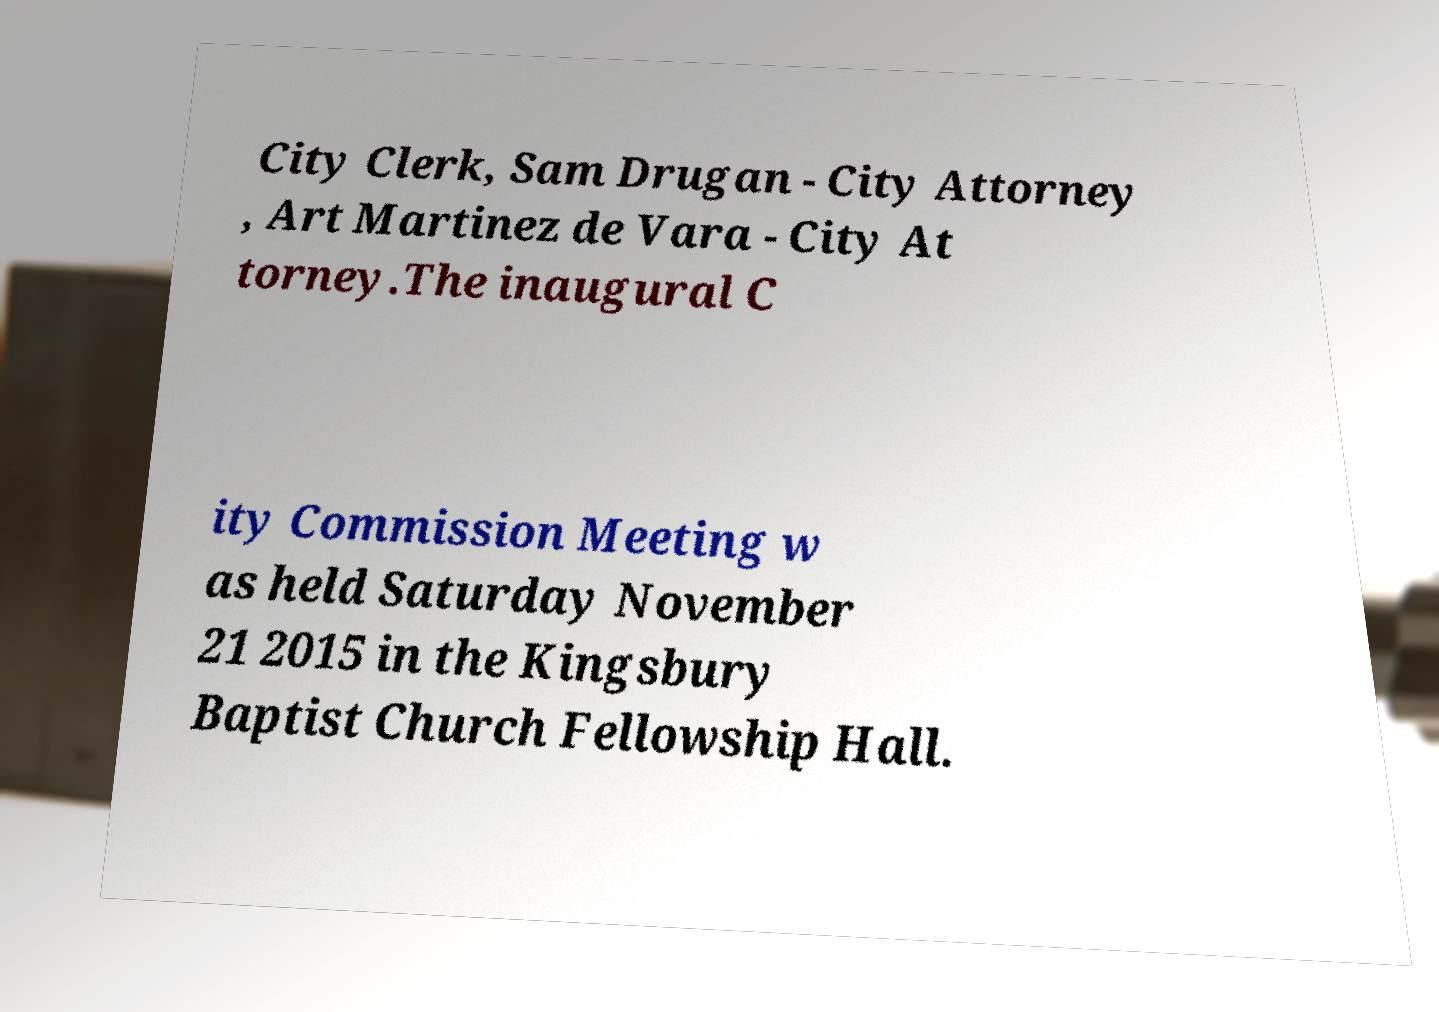Please identify and transcribe the text found in this image. City Clerk, Sam Drugan - City Attorney , Art Martinez de Vara - City At torney.The inaugural C ity Commission Meeting w as held Saturday November 21 2015 in the Kingsbury Baptist Church Fellowship Hall. 